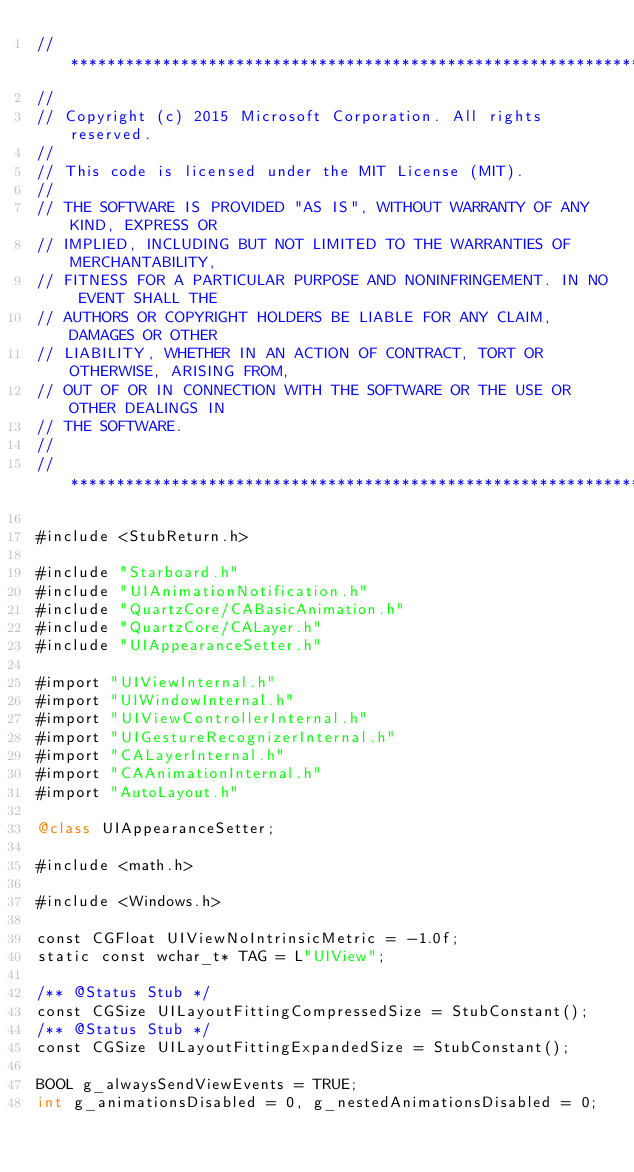<code> <loc_0><loc_0><loc_500><loc_500><_ObjectiveC_>//******************************************************************************
//
// Copyright (c) 2015 Microsoft Corporation. All rights reserved.
//
// This code is licensed under the MIT License (MIT).
//
// THE SOFTWARE IS PROVIDED "AS IS", WITHOUT WARRANTY OF ANY KIND, EXPRESS OR
// IMPLIED, INCLUDING BUT NOT LIMITED TO THE WARRANTIES OF MERCHANTABILITY,
// FITNESS FOR A PARTICULAR PURPOSE AND NONINFRINGEMENT. IN NO EVENT SHALL THE
// AUTHORS OR COPYRIGHT HOLDERS BE LIABLE FOR ANY CLAIM, DAMAGES OR OTHER
// LIABILITY, WHETHER IN AN ACTION OF CONTRACT, TORT OR OTHERWISE, ARISING FROM,
// OUT OF OR IN CONNECTION WITH THE SOFTWARE OR THE USE OR OTHER DEALINGS IN
// THE SOFTWARE.
//
//******************************************************************************

#include <StubReturn.h>

#include "Starboard.h"
#include "UIAnimationNotification.h"
#include "QuartzCore/CABasicAnimation.h"
#include "QuartzCore/CALayer.h"
#include "UIAppearanceSetter.h"

#import "UIViewInternal.h"
#import "UIWindowInternal.h"
#import "UIViewControllerInternal.h"
#import "UIGestureRecognizerInternal.h"
#import "CALayerInternal.h"
#import "CAAnimationInternal.h"
#import "AutoLayout.h"

@class UIAppearanceSetter;

#include <math.h>

#include <Windows.h>

const CGFloat UIViewNoIntrinsicMetric = -1.0f;
static const wchar_t* TAG = L"UIView";

/** @Status Stub */
const CGSize UILayoutFittingCompressedSize = StubConstant();
/** @Status Stub */
const CGSize UILayoutFittingExpandedSize = StubConstant();

BOOL g_alwaysSendViewEvents = TRUE;
int g_animationsDisabled = 0, g_nestedAnimationsDisabled = 0;</code> 